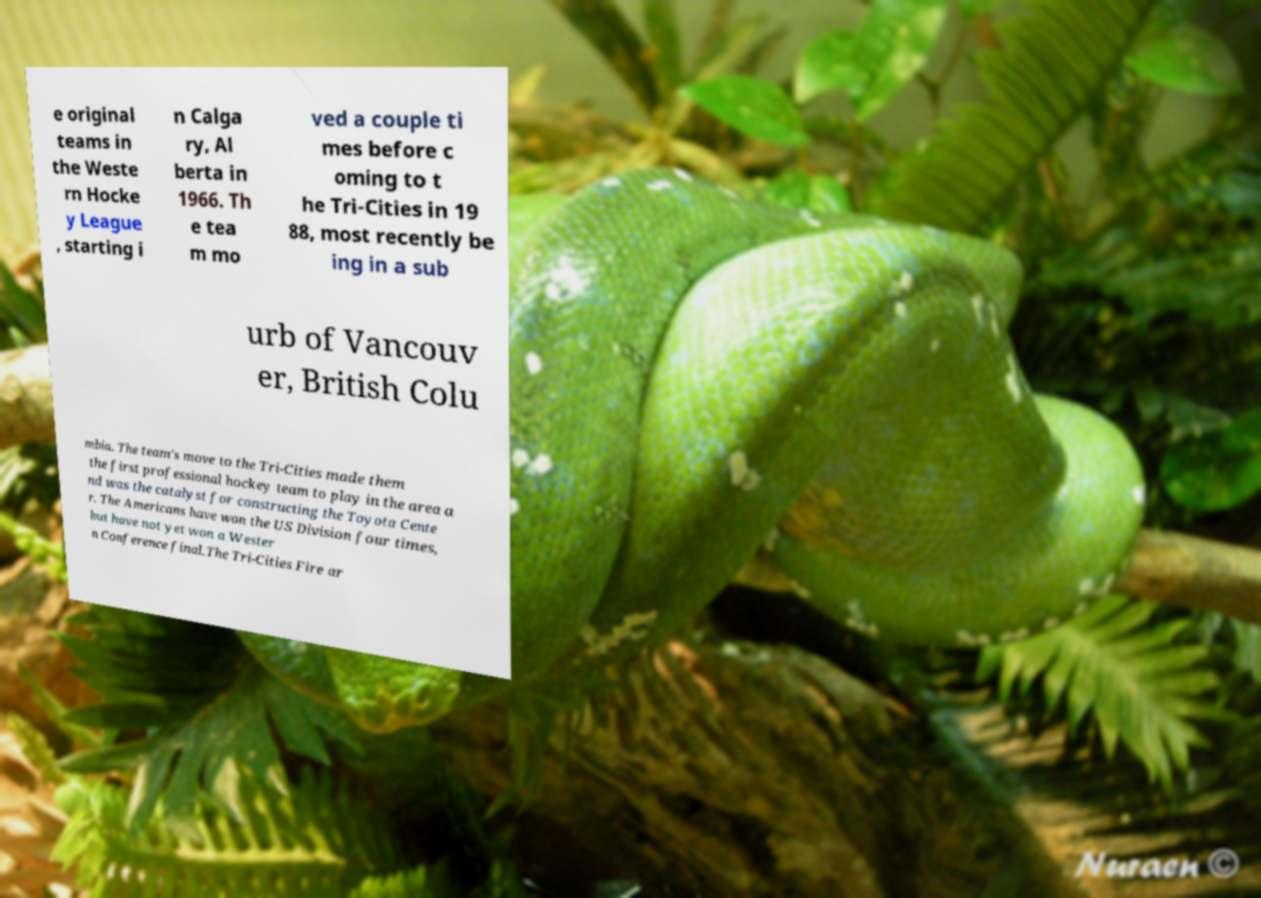What messages or text are displayed in this image? I need them in a readable, typed format. e original teams in the Weste rn Hocke y League , starting i n Calga ry, Al berta in 1966. Th e tea m mo ved a couple ti mes before c oming to t he Tri-Cities in 19 88, most recently be ing in a sub urb of Vancouv er, British Colu mbia. The team's move to the Tri-Cities made them the first professional hockey team to play in the area a nd was the catalyst for constructing the Toyota Cente r. The Americans have won the US Division four times, but have not yet won a Wester n Conference final.The Tri-Cities Fire ar 